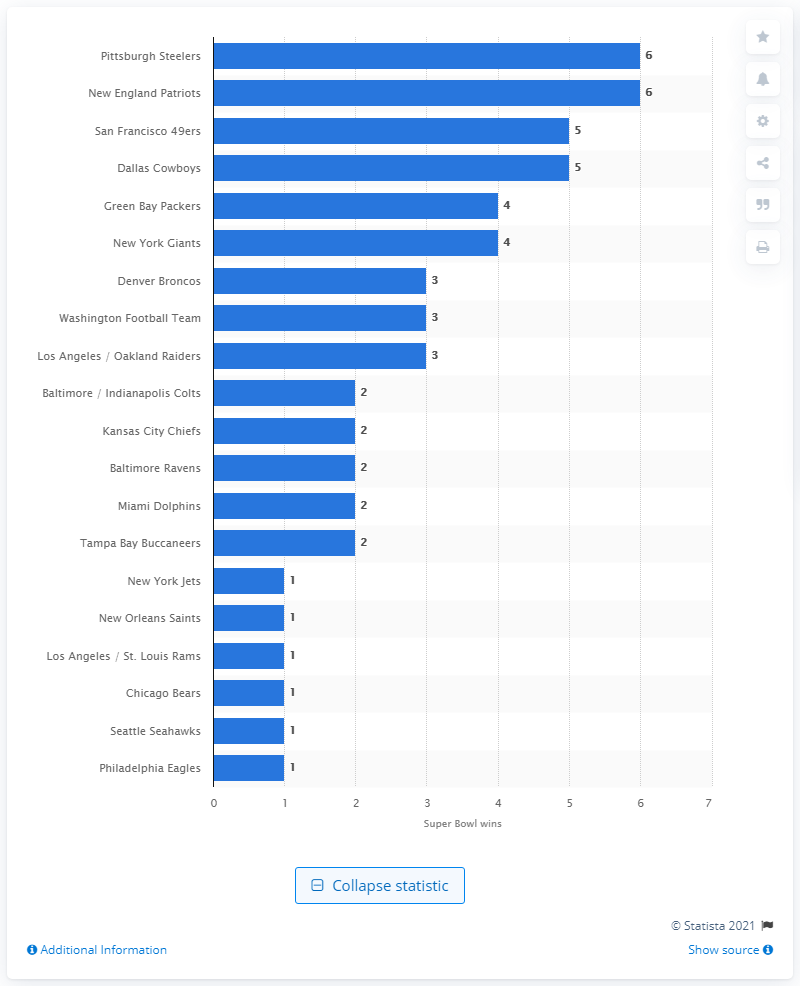Specify some key components in this picture. The Pittsburgh Steelers have won the most Super Bowls. 